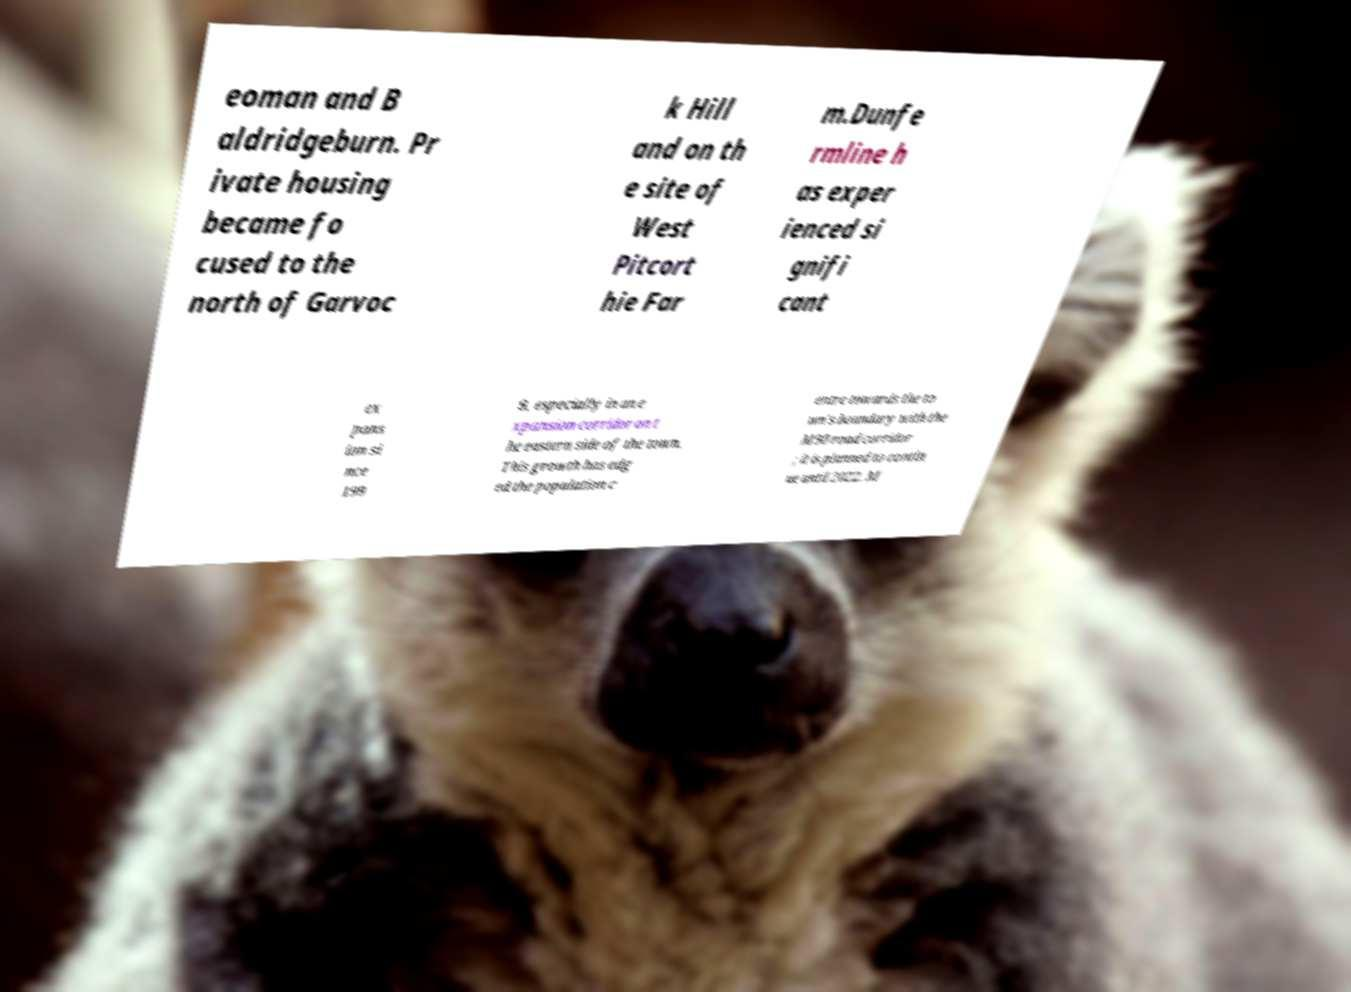Could you assist in decoding the text presented in this image and type it out clearly? eoman and B aldridgeburn. Pr ivate housing became fo cused to the north of Garvoc k Hill and on th e site of West Pitcort hie Far m.Dunfe rmline h as exper ienced si gnifi cant ex pans ion si nce 199 9, especially in an e xpansion corridor on t he eastern side of the town. This growth has edg ed the population c entre towards the to wn's boundary with the M90 road corridor ; it is planned to contin ue until 2022. M 